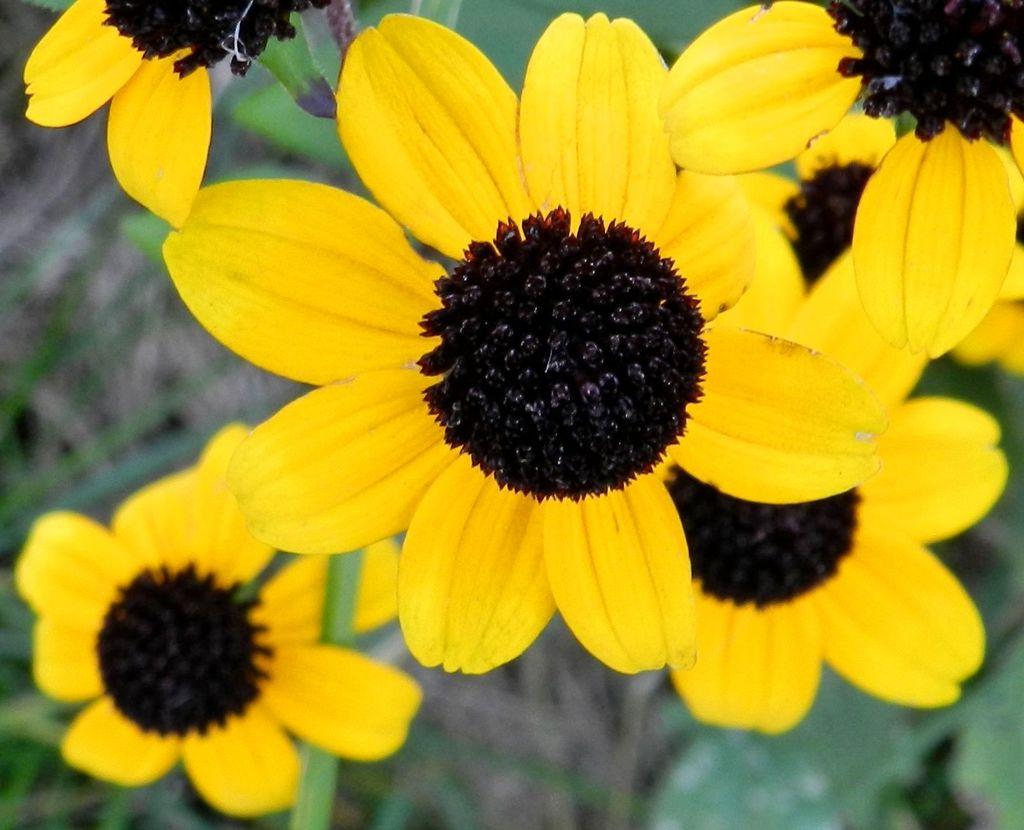What type of living organisms can be seen in the image? There are flowers on a plant in the image. Can you describe the background of the image? The background of the image is blurred. What type of prose is the woman reading in the image? There is no woman present in the image. 